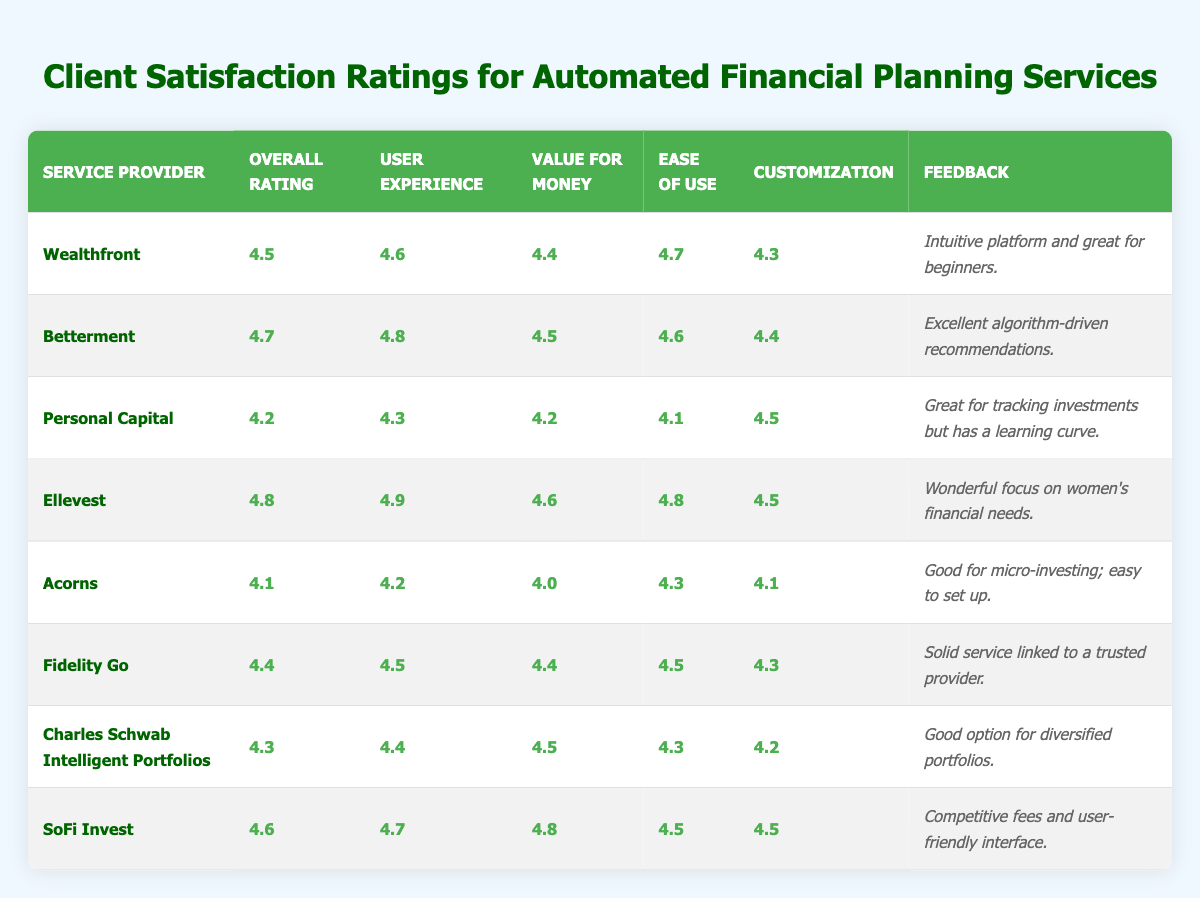What is the overall rating of Ellevest? The table shows that Ellevest has an overall rating of 4.8 listed under its respective row.
Answer: 4.8 Which service provider has the highest user experience rating? By analyzing the user experience ratings, Ellevest has the highest rating at 4.9 compared to others.
Answer: Ellevest What is the average value for money rating across all service providers? To find the average, sum the value for money ratings (4.4 + 4.5 + 4.2 + 4.6 + 4.0 + 4.4 + 4.5 + 4.8 = 35.4) and divide by the number of providers (8): 35.4/8 = 4.425.
Answer: 4.425 Does Betterment have a lower overall rating than Wealthfront? Betterment has an overall rating of 4.7 while Wealthfront has 4.5, which means Betterment's rating is higher.
Answer: No Which provider has the lowest value for money rating? Acorns has a value for money rating of 4.0, the lowest among all listed service providers.
Answer: Acorns How does the ease of use rating for Personal Capital compare to that of SoFi Invest? Personal Capital has an ease of use rating of 4.1, while SoFi Invest has a rating of 4.5, indicating that SoFi is rated higher.
Answer: SoFi Invest is higher What is the difference in overall ratings between Ellevest and Acorns? Ellevest has an overall rating of 4.8 while Acorns has 4.1, so the difference is 4.8 - 4.1 = 0.7.
Answer: 0.7 Are the customization ratings for Fidelity Go and Charles Schwab Intelligent Portfolios the same? Fidelity Go has a customization rating of 4.3 while Charles Schwab Intelligent Portfolios has 4.2; therefore, they are not the same.
Answer: No Which service provider has both the highest user experience rating and highest overall rating? Ellevest has both the highest overall rating (4.8) and the highest user experience rating (4.9), making it the only provider with this distinction.
Answer: Ellevest If you take the average of all ease of use ratings, what would it be? To calculate, sum the ease of use ratings (4.7 + 4.6 + 4.1 + 4.8 + 4.3 + 4.5 + 4.3 + 4.5 = 36.8) and divide by the number of providers (8): 36.8/8 = 4.6.
Answer: 4.6 Which service provider offers the best value for money based on the ratings? SoFi Invest has the highest value for money rating at 4.8, indicating it offers the best value compared to others.
Answer: SoFi Invest 